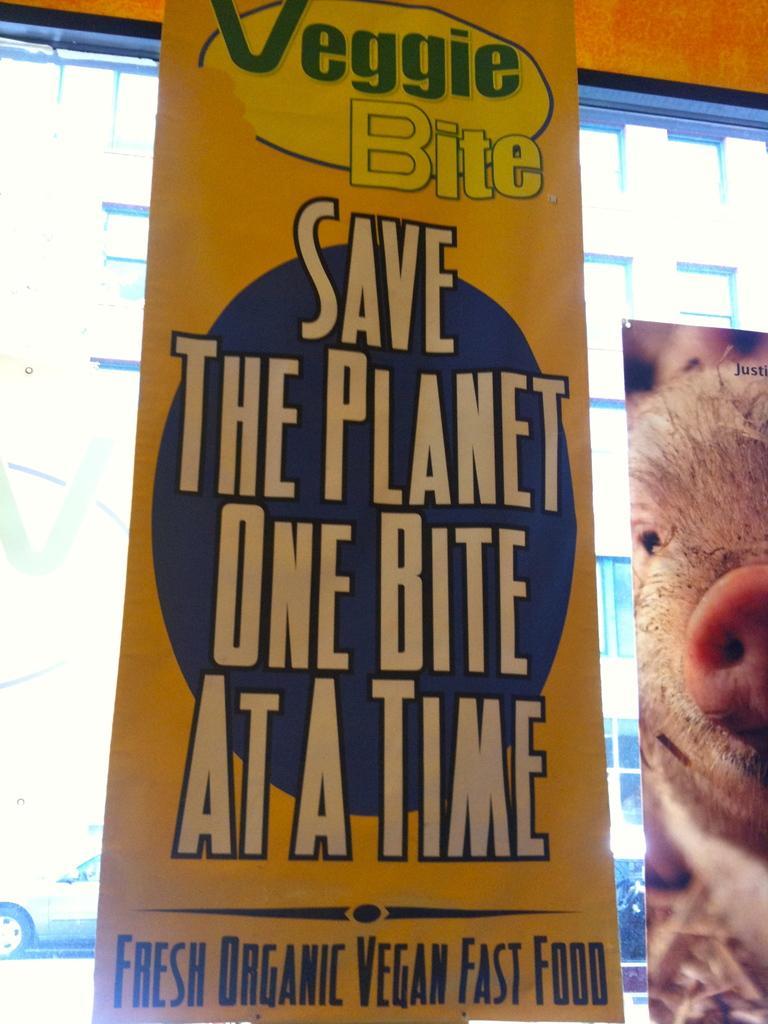Can you describe this image briefly? In this image we can see a banner and the picture of a pig beside a window. We can also see a car on the backside. 